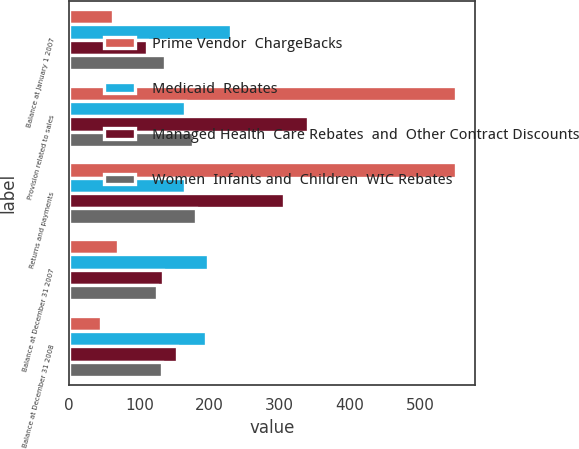<chart> <loc_0><loc_0><loc_500><loc_500><stacked_bar_chart><ecel><fcel>Balance at January 1 2007<fcel>Provision related to sales<fcel>Returns and payments<fcel>Balance at December 31 2007<fcel>Balance at December 31 2008<nl><fcel>Prime Vendor  ChargeBacks<fcel>63<fcel>551<fcel>551<fcel>70<fcel>45<nl><fcel>Medicaid  Rebates<fcel>230<fcel>165<fcel>165<fcel>198<fcel>195<nl><fcel>Managed Health  Care Rebates  and  Other Contract Discounts<fcel>111<fcel>340<fcel>306<fcel>134<fcel>154<nl><fcel>Women  Infants and  Children  WIC Rebates<fcel>137<fcel>176<fcel>181<fcel>125<fcel>133<nl></chart> 